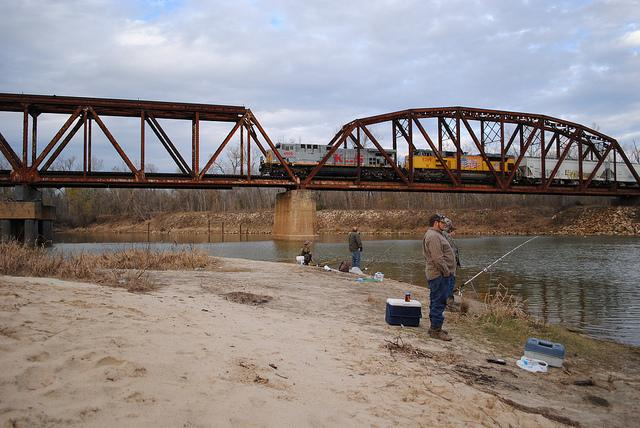What do the men hope to bring home? Please explain your reasoning. fish. Men are standing on the shore with fishing poles. 